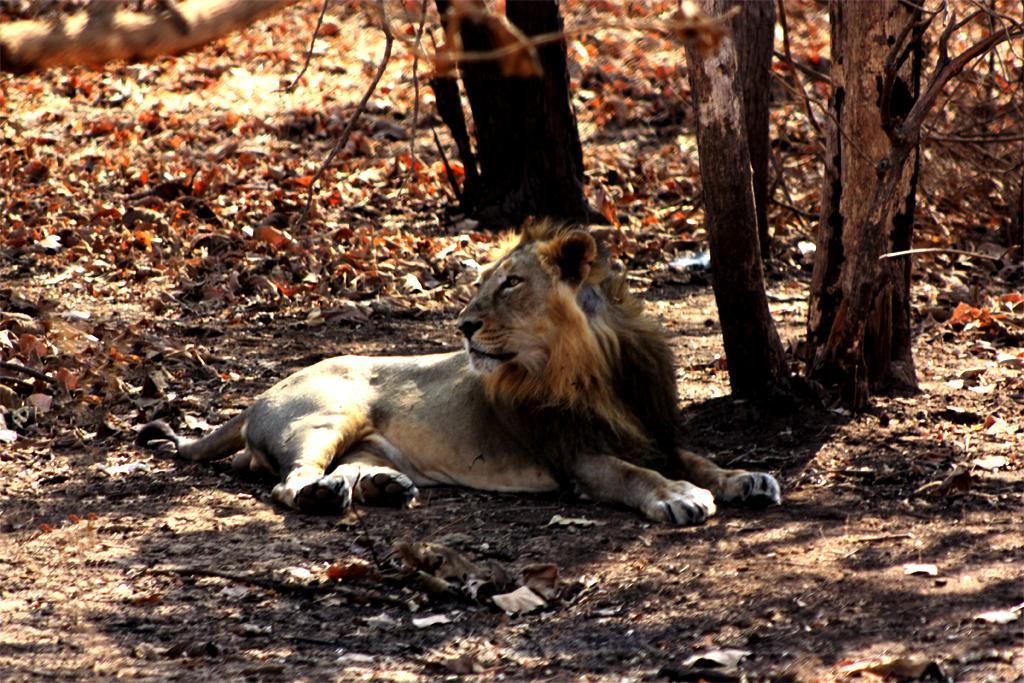In one or two sentences, can you explain what this image depicts? In this image I can see a lion. There are tree trunks and branches. Also there are leaves on the ground. 